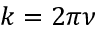Convert formula to latex. <formula><loc_0><loc_0><loc_500><loc_500>k = 2 \pi \nu</formula> 